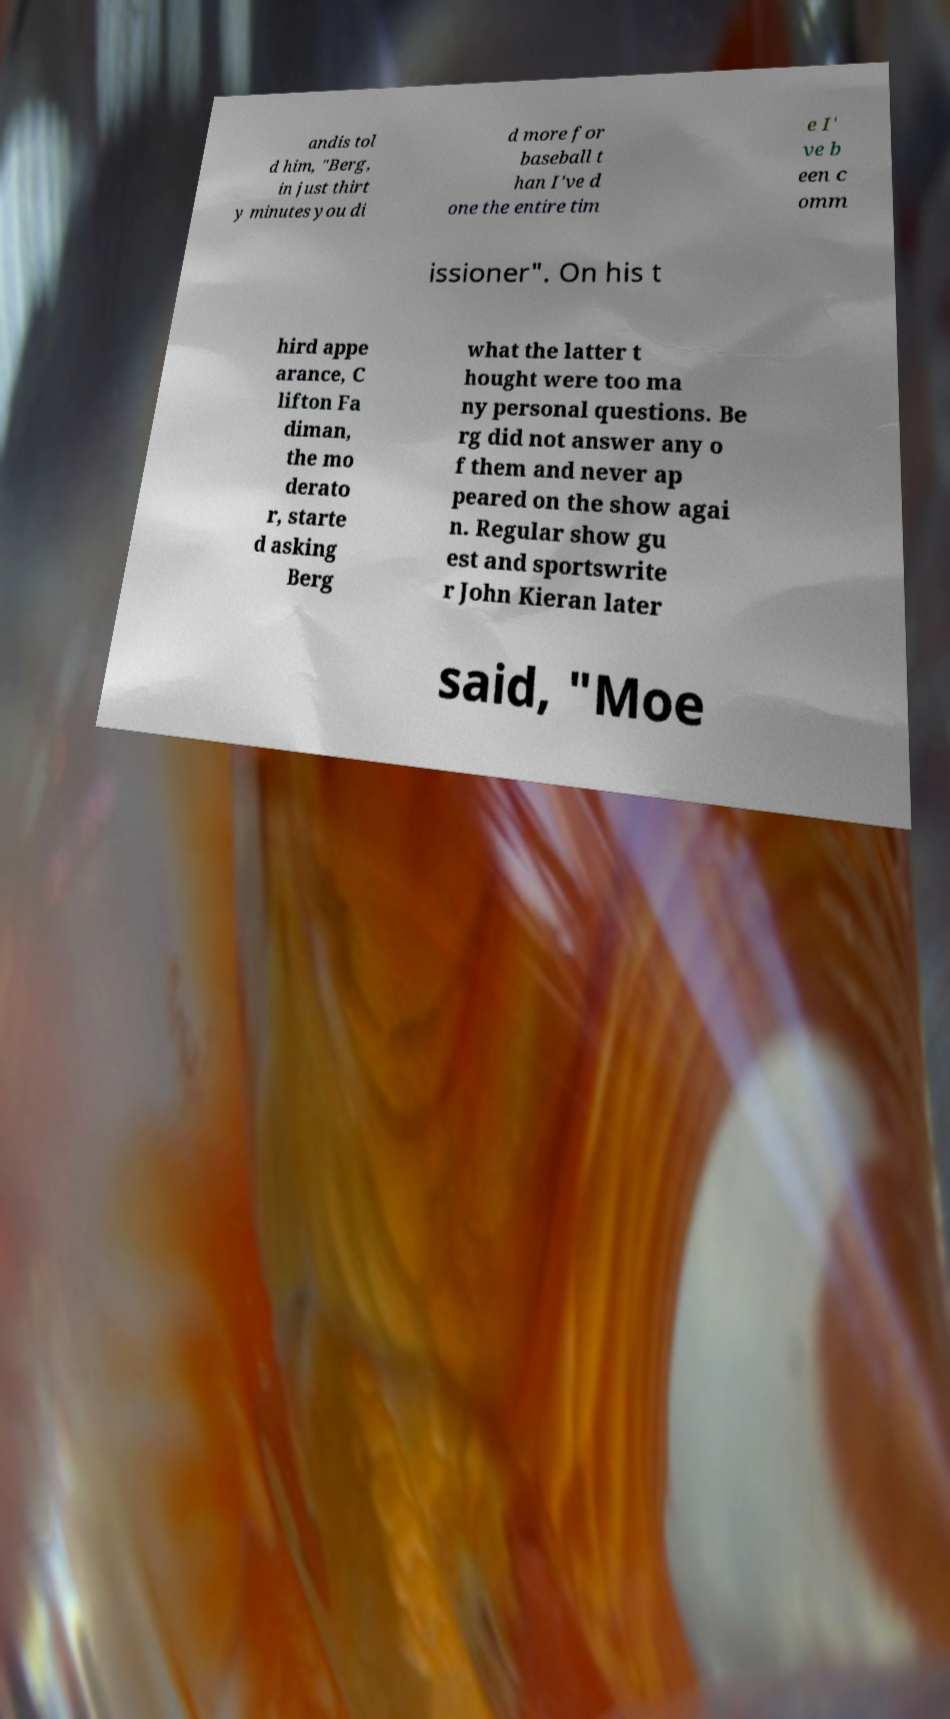Please identify and transcribe the text found in this image. andis tol d him, "Berg, in just thirt y minutes you di d more for baseball t han I've d one the entire tim e I' ve b een c omm issioner". On his t hird appe arance, C lifton Fa diman, the mo derato r, starte d asking Berg what the latter t hought were too ma ny personal questions. Be rg did not answer any o f them and never ap peared on the show agai n. Regular show gu est and sportswrite r John Kieran later said, "Moe 